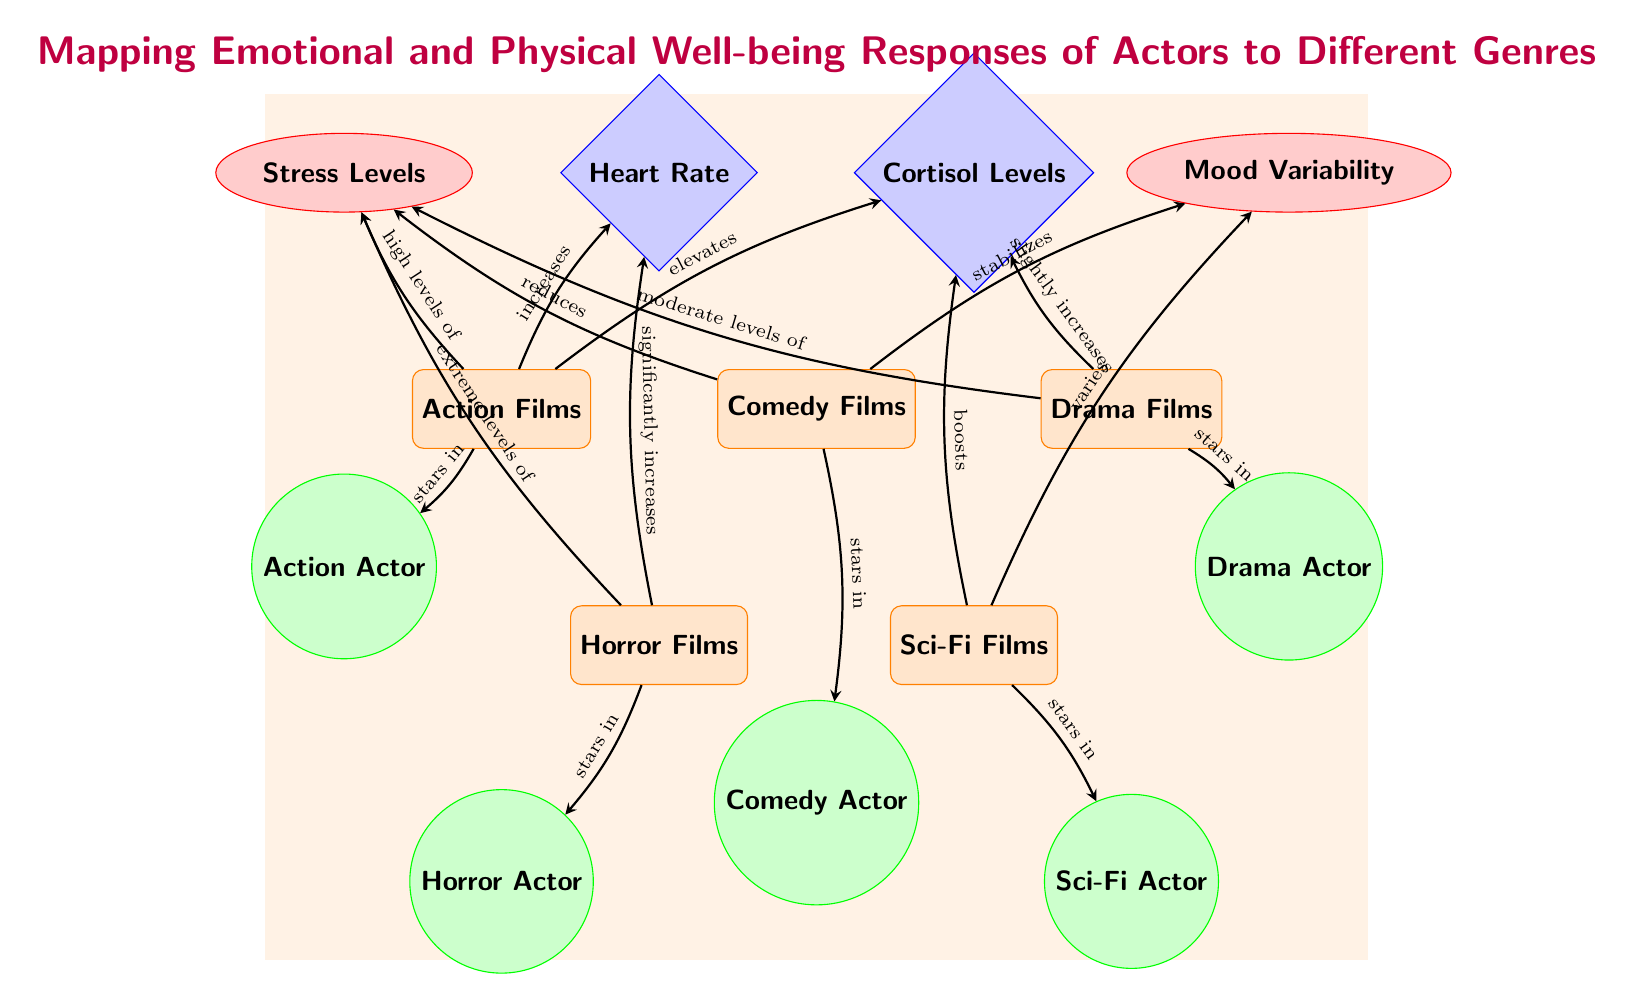What's the emotional response most associated with Action Films? According to the diagram, Action Films are linked with "high levels of" Stress. This can be confirmed by following the edge from Action Films to the Stress Levels node, where the relationship is explicitly labeled.
Answer: high levels of Which genre leads to reduced stress levels? The diagram shows a direct connection from Comedy Films to Stress Levels, indicating that Comedy Films "reduces" stress, as labeled on the edge.
Answer: Comedy Films What is the physical response significantly increased by Horror Films? Following the edge from Horror Films, it states it "significantly increases" Heart Rate. This relationship is clearly presented in the diagram.
Answer: Heart Rate How many genres of film are represented in the diagram? By counting the genre nodes (Action, Comedy, Drama, Horror, and Sci-Fi), we find there are a total of five genres represented. This is evident in the main row of genre nodes.
Answer: five Which actor genre is associated with moderate levels of stress? The Drama Films node indicates it relates to "moderate levels of" Stress through its connection to the Stress Levels node, identifying Drama as the genre.
Answer: Drama Films What is the relationship between Sci-Fi Films and mood? The diagram indicates that Sci-Fi Films "varies" Mood Variability. The connection is explicitly represented by the edge from Sci-Fi to Mood Variability.
Answer: varies Which genre is linked to extremely high stress levels? Horror Films are shown to be associated with "extreme levels of" Stress, as indicated by the direct edge connecting Horror Films to Stress Levels.
Answer: Horror Films List the physical responses highlighted in the diagram. The physical responses included are Heart Rate and Cortisol Levels, found on the physical node shapes under the respective genre connections, as labeled in the diagram.
Answer: Heart Rate, Cortisol Levels 